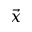<formula> <loc_0><loc_0><loc_500><loc_500>\vec { x }</formula> 